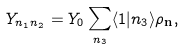<formula> <loc_0><loc_0><loc_500><loc_500>Y _ { n _ { 1 } n _ { 2 } } = Y _ { 0 } \sum _ { n _ { 3 } } \langle 1 | n _ { 3 } \rangle \rho _ { \mathbf n } ,</formula> 